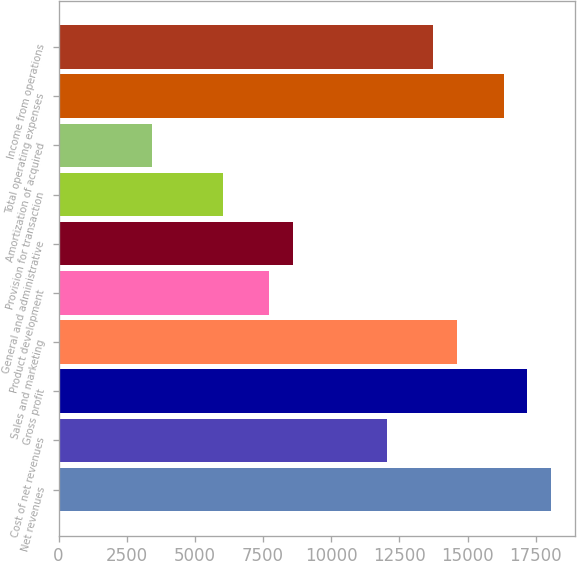Convert chart to OTSL. <chart><loc_0><loc_0><loc_500><loc_500><bar_chart><fcel>Net revenues<fcel>Cost of net revenues<fcel>Gross profit<fcel>Sales and marketing<fcel>Product development<fcel>General and administrative<fcel>Provision for transaction<fcel>Amortization of acquired<fcel>Total operating expenses<fcel>Income from operations<nl><fcel>18043<fcel>12028.7<fcel>17183.8<fcel>14606.2<fcel>7732.8<fcel>8591.98<fcel>6014.44<fcel>3436.9<fcel>16324.6<fcel>13747.1<nl></chart> 